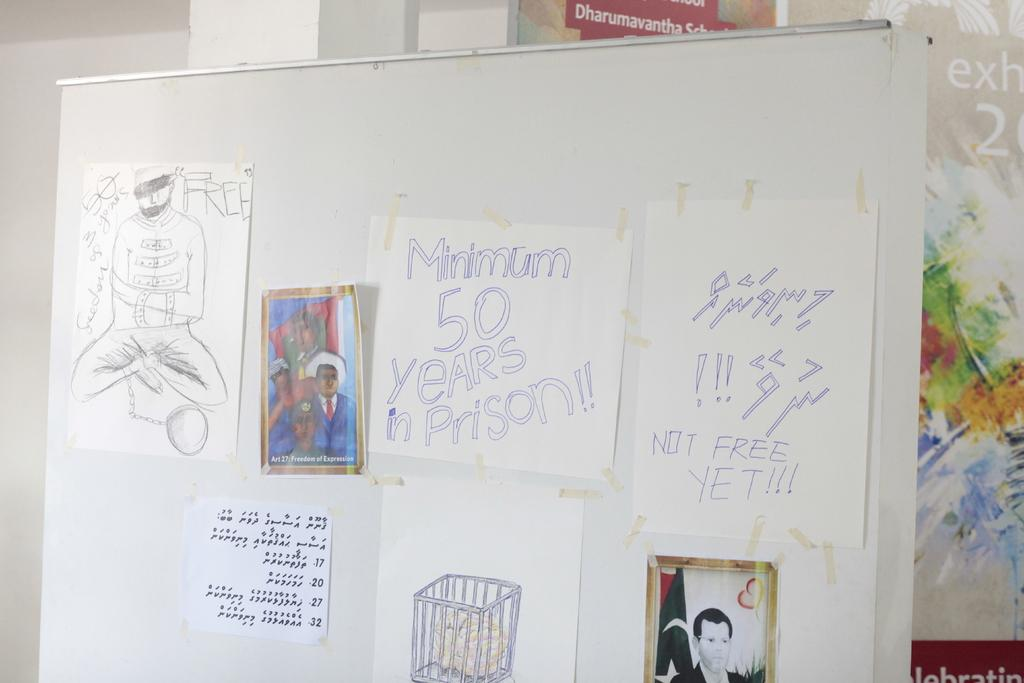<image>
Describe the image concisely. A white board with multiple pictures/drawings hung, one of them says Minimum 50 years in prison. 